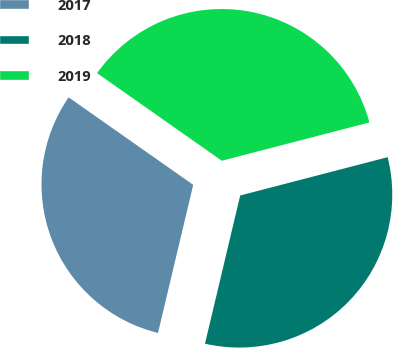Convert chart to OTSL. <chart><loc_0><loc_0><loc_500><loc_500><pie_chart><fcel>2017<fcel>2018<fcel>2019<nl><fcel>31.03%<fcel>32.76%<fcel>36.21%<nl></chart> 